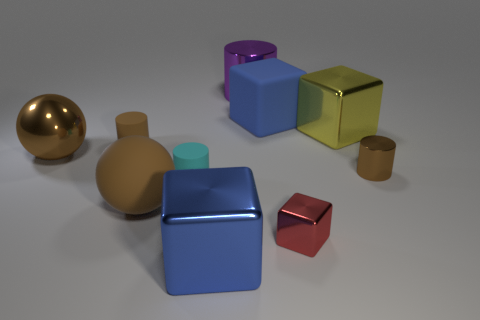Subtract all spheres. How many objects are left? 8 Subtract 0 yellow cylinders. How many objects are left? 10 Subtract all small objects. Subtract all tiny green spheres. How many objects are left? 6 Add 6 cyan rubber cylinders. How many cyan rubber cylinders are left? 7 Add 9 red balls. How many red balls exist? 9 